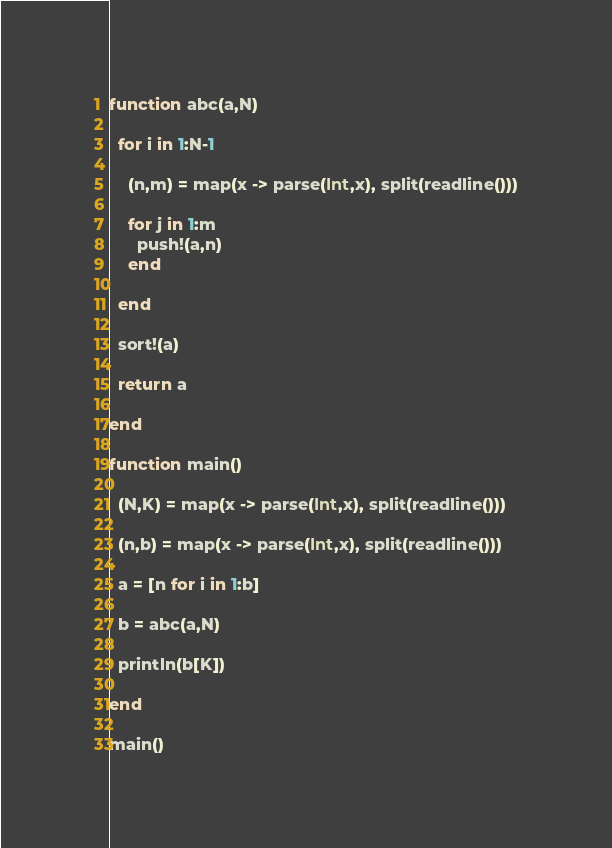<code> <loc_0><loc_0><loc_500><loc_500><_Julia_>function abc(a,N)

  for i in 1:N-1
    
    (n,m) = map(x -> parse(Int,x), split(readline()))
    
    for j in 1:m
      push!(a,n)
    end
    
  end
  
  sort!(a)
  
  return a
  
end

function main()
  
  (N,K) = map(x -> parse(Int,x), split(readline()))
  
  (n,b) = map(x -> parse(Int,x), split(readline()))
  
  a = [n for i in 1:b]

  b = abc(a,N)
  
  println(b[K])
  
end

main()</code> 